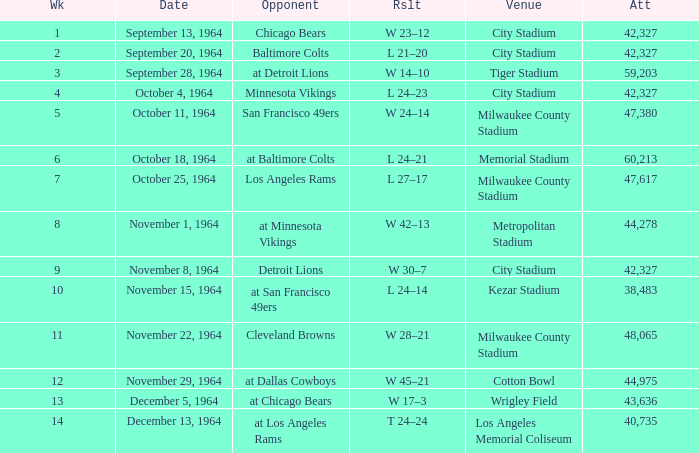What is the average week of the game on November 22, 1964 attended by 48,065? None. 